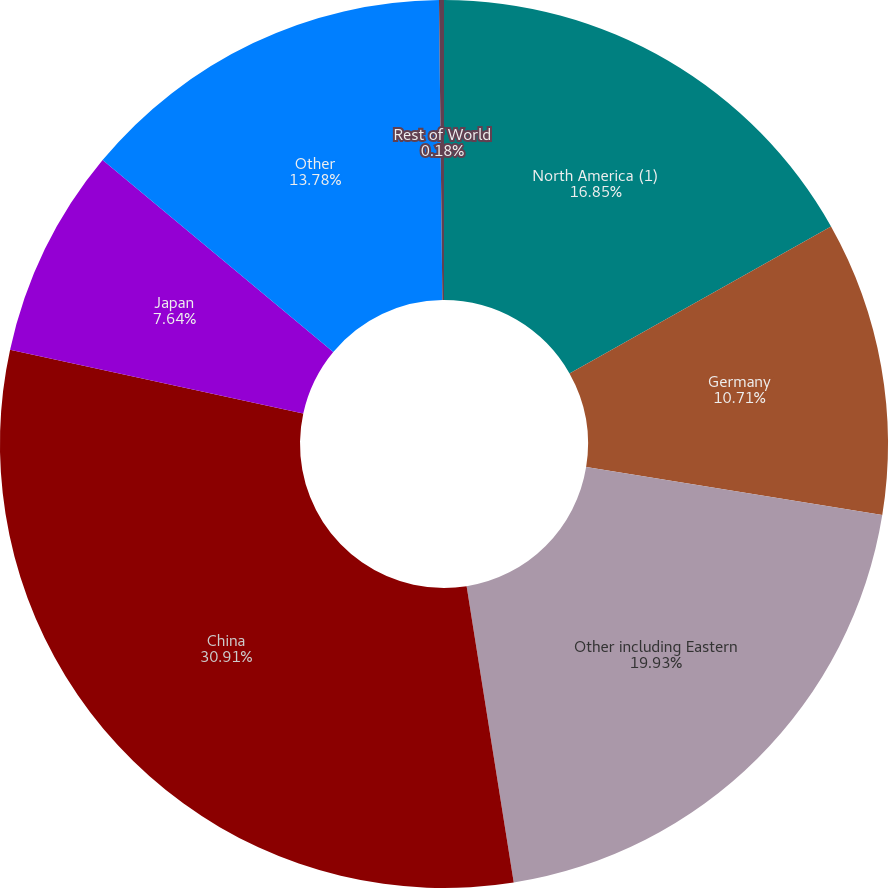Convert chart. <chart><loc_0><loc_0><loc_500><loc_500><pie_chart><fcel>North America (1)<fcel>Germany<fcel>Other including Eastern<fcel>China<fcel>Japan<fcel>Other<fcel>Rest of World<nl><fcel>16.85%<fcel>10.71%<fcel>19.93%<fcel>30.91%<fcel>7.64%<fcel>13.78%<fcel>0.18%<nl></chart> 